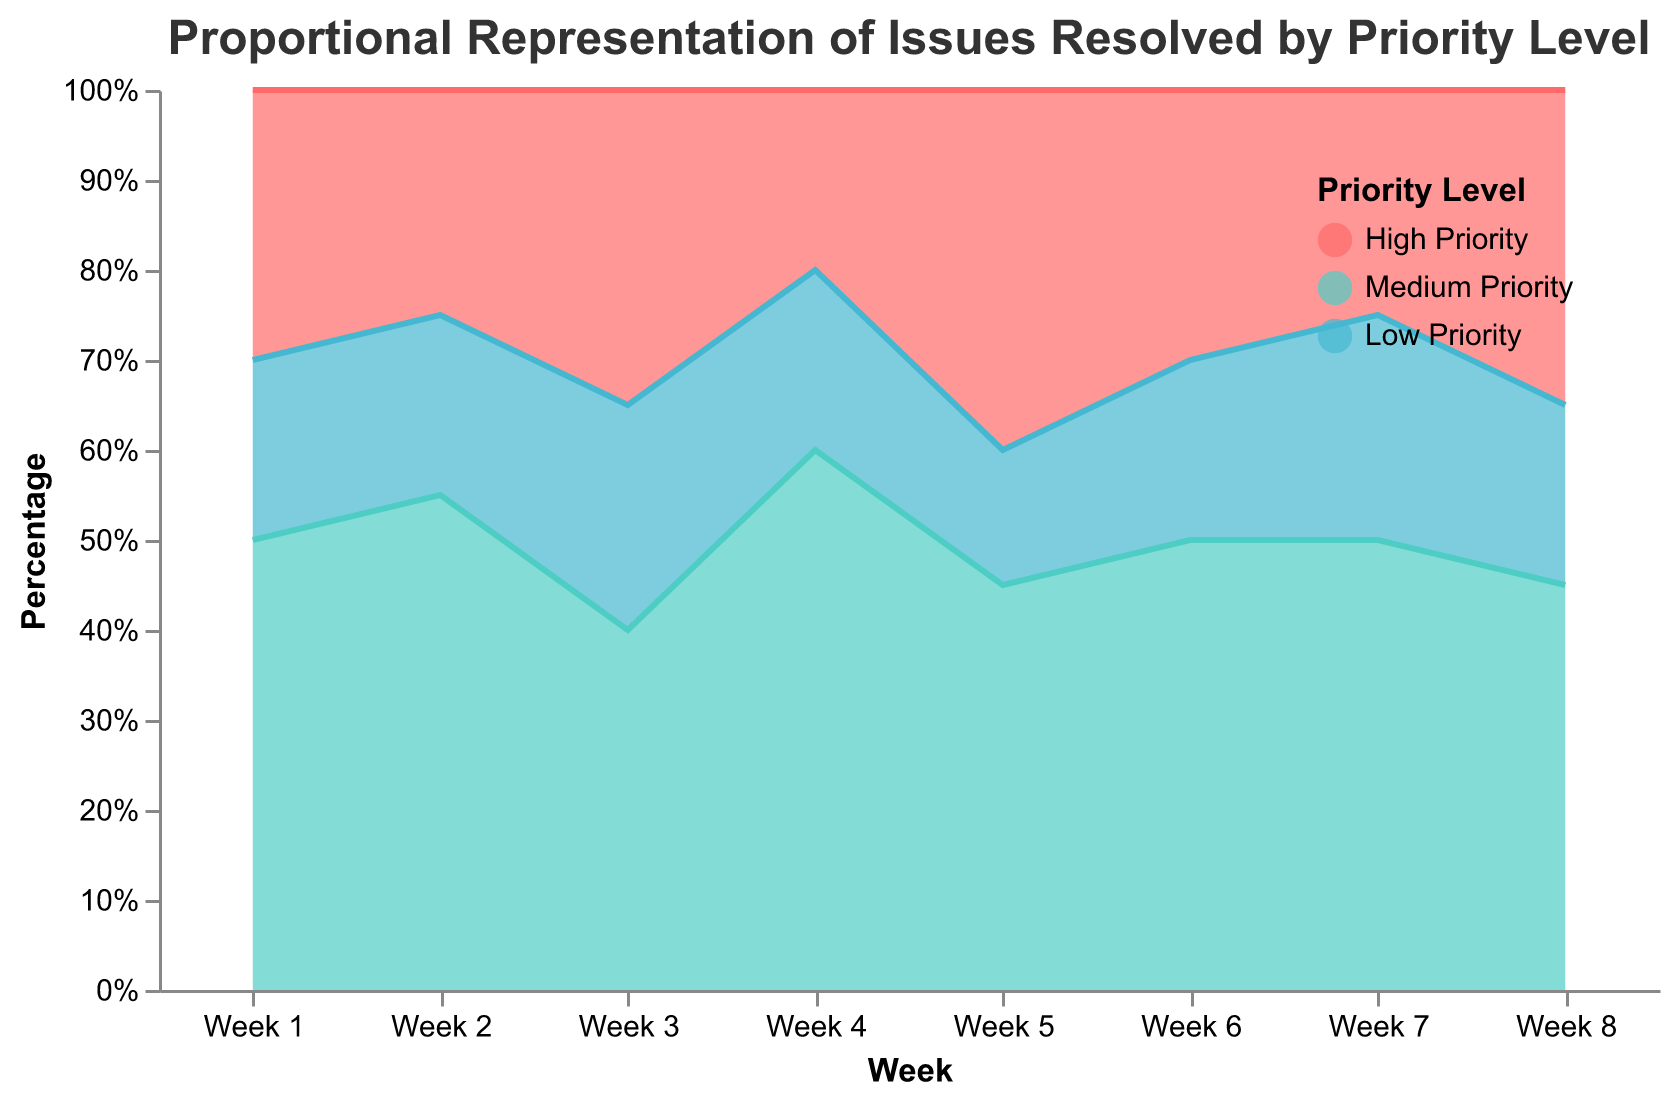What's the title of the chart? The title of the chart is located at the top of the figure. It reads "Proportional Representation of Issues Resolved by Priority Level".
Answer: Proportional Representation of Issues Resolved by Priority Level Which color represents the Low Priority issues? The color representing Low Priority issues can be identified by looking at the legend. The color is light blue.
Answer: Light blue In Week 4, which priority level had the highest percentage share? In Week 4, the chart shows that Medium Priority issues (represented in green) occupy the largest area.
Answer: Medium Priority How does the proportion of High Priority issues in Week 5 compare to Week 4? In Week 5, the proportion of High Priority issues is larger compared to Week 4, which can be identified by observing the relative area sizes for High Priority issues.
Answer: Larger What is the trend in the proportion of Medium Priority issues from Week 1 to Week 4? From Week 1 to Week 4, the proportion of Medium Priority issues shows an increasing trend, as the area representing them grows each week.
Answer: Increasing Which week had the lowest proportion of Low Priority issues? The week with the lowest proportion of Low Priority issues can be found by identifying the week with the smallest light blue area, which is Week 5.
Answer: Week 5 Compare the total proportions of all priority levels in Week 2 to Week 6. In both Week 2 and Week 6, the proportions add up to 100% (normalized chart) but Week 2 has a higher percentage of Medium Priority issues and a lower percentage of High Priority issues compared to Week 6.
Answer: Different composition, same total How does the area representing Medium Priority issues change between Week 6 and Week 8? The area representing Medium Priority issues decreases from Week 6 to Week 8, as observed by a reduction in the green area.
Answer: Decreases Is there any week where all three priority levels have the same proportional share? By evaluating the proportional areas, no week shows an equal share of all three priority levels.
Answer: No What is the highest proportion of High Priority issues achieved in any week? The highest proportion of High Priority issues is observed in Week 5, where the red area is the largest compared to other weeks.
Answer: Week 5 